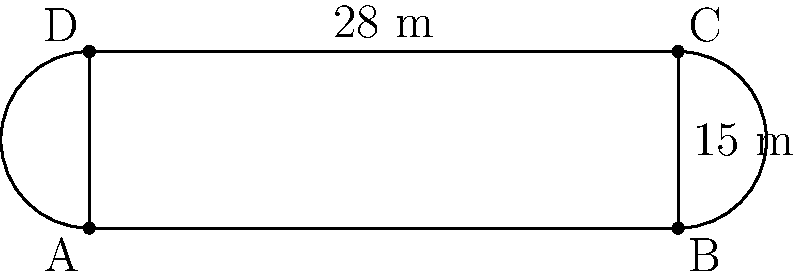In honor of Christian Larièpe's contributions to local basketball, the city is designing a new court named after him. The court has a rectangular center with semicircular ends, as shown in the diagram. If the length of the rectangular part is 28 meters and the width of the court is 15 meters, what is the perimeter of the entire court? Let's approach this step-by-step:

1) First, we need to identify the components of the perimeter:
   - Two straight sides (the length of the rectangle)
   - Two semicircles (at each end)

2) The length of the rectangular part is given as 28 meters.

3) For the semicircles, we need to calculate their circumference:
   - The width of the court is 15 meters, which is the diameter of a full circle
   - The radius is half of this: $15 \div 2 = 7.5$ meters

4) The formula for the circumference of a circle is $2\pi r$, where $r$ is the radius.
   For a semicircle, we need half of this: $\pi r$

5) Calculating the length of one semicircle:
   $\pi \times 7.5 \approx 23.56$ meters

6) Now, let's add up all parts of the perimeter:
   - Two straight sides: $28 \times 2 = 56$ meters
   - Two semicircles: $23.56 \times 2 \approx 47.12$ meters

7) Total perimeter: $56 + 47.12 = 103.12$ meters

Therefore, the perimeter of the entire court is approximately 103.12 meters.
Answer: $103.12$ meters 